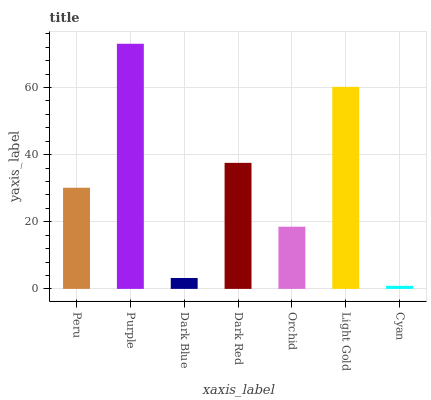Is Cyan the minimum?
Answer yes or no. Yes. Is Purple the maximum?
Answer yes or no. Yes. Is Dark Blue the minimum?
Answer yes or no. No. Is Dark Blue the maximum?
Answer yes or no. No. Is Purple greater than Dark Blue?
Answer yes or no. Yes. Is Dark Blue less than Purple?
Answer yes or no. Yes. Is Dark Blue greater than Purple?
Answer yes or no. No. Is Purple less than Dark Blue?
Answer yes or no. No. Is Peru the high median?
Answer yes or no. Yes. Is Peru the low median?
Answer yes or no. Yes. Is Purple the high median?
Answer yes or no. No. Is Cyan the low median?
Answer yes or no. No. 